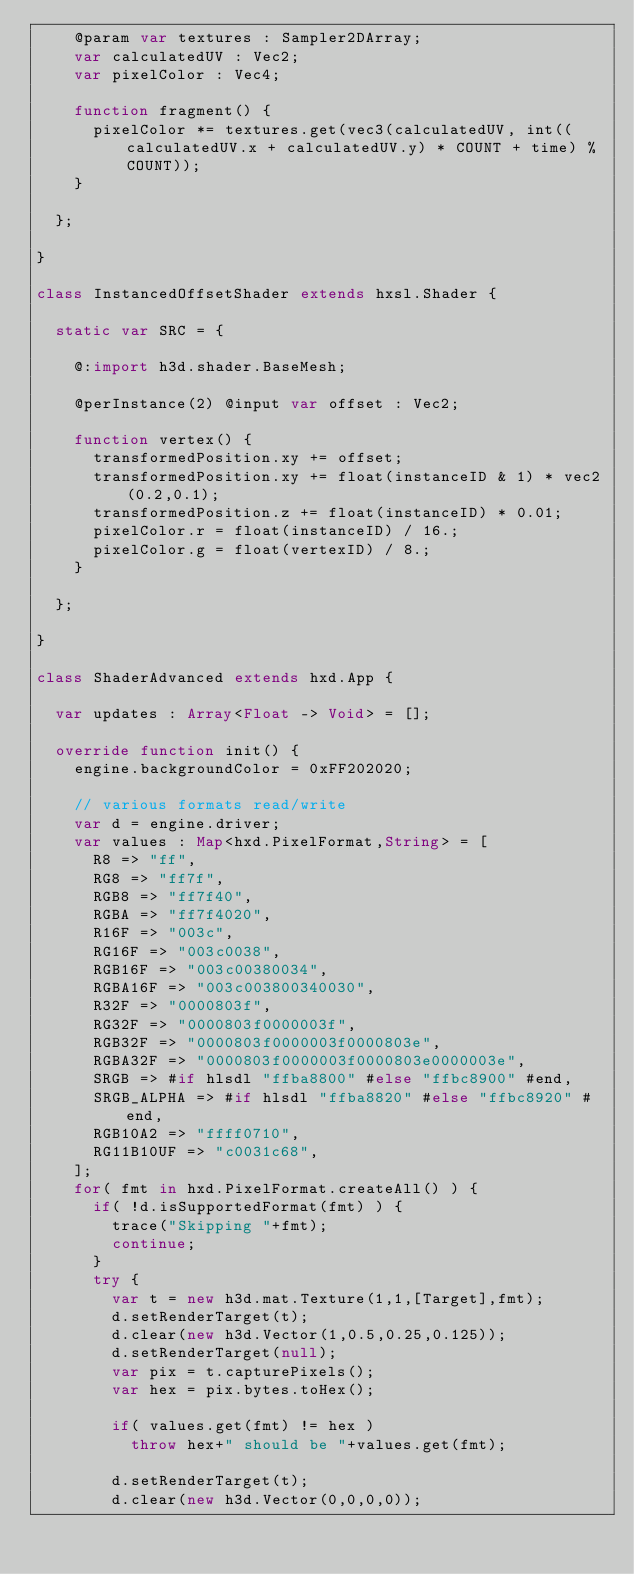Convert code to text. <code><loc_0><loc_0><loc_500><loc_500><_Haxe_>		@param var textures : Sampler2DArray;
		var calculatedUV : Vec2;
		var pixelColor : Vec4;

		function fragment() {
			pixelColor *= textures.get(vec3(calculatedUV, int((calculatedUV.x + calculatedUV.y) * COUNT + time) % COUNT));
		}

	};

}

class InstancedOffsetShader extends hxsl.Shader {

	static var SRC = {

		@:import h3d.shader.BaseMesh;

		@perInstance(2) @input var offset : Vec2;

		function vertex() {
			transformedPosition.xy += offset;
			transformedPosition.xy += float(instanceID & 1) * vec2(0.2,0.1);
			transformedPosition.z += float(instanceID) * 0.01;
			pixelColor.r = float(instanceID) / 16.;
			pixelColor.g = float(vertexID) / 8.;
		}

	};

}

class ShaderAdvanced extends hxd.App {

	var updates : Array<Float -> Void> = [];

	override function init() {
		engine.backgroundColor = 0xFF202020;

		// various formats read/write
		var d = engine.driver;
		var values : Map<hxd.PixelFormat,String> = [
			R8 => "ff",
			RG8 => "ff7f",
			RGB8 => "ff7f40",
			RGBA => "ff7f4020",
			R16F => "003c",
			RG16F => "003c0038",
			RGB16F => "003c00380034",
			RGBA16F => "003c003800340030",
			R32F => "0000803f",
			RG32F => "0000803f0000003f",
			RGB32F => "0000803f0000003f0000803e",
			RGBA32F => "0000803f0000003f0000803e0000003e",
			SRGB => #if hlsdl "ffba8800" #else "ffbc8900" #end,
			SRGB_ALPHA => #if hlsdl "ffba8820" #else "ffbc8920" #end,
			RGB10A2 => "ffff0710",
			RG11B10UF => "c0031c68",
		];
		for( fmt in hxd.PixelFormat.createAll() ) {
			if( !d.isSupportedFormat(fmt) ) {
				trace("Skipping "+fmt);
				continue;
			}
			try {
				var t = new h3d.mat.Texture(1,1,[Target],fmt);
				d.setRenderTarget(t);
				d.clear(new h3d.Vector(1,0.5,0.25,0.125));
				d.setRenderTarget(null);
				var pix = t.capturePixels();
				var hex = pix.bytes.toHex();

				if( values.get(fmt) != hex )
					throw hex+" should be "+values.get(fmt);

				d.setRenderTarget(t);
				d.clear(new h3d.Vector(0,0,0,0));</code> 